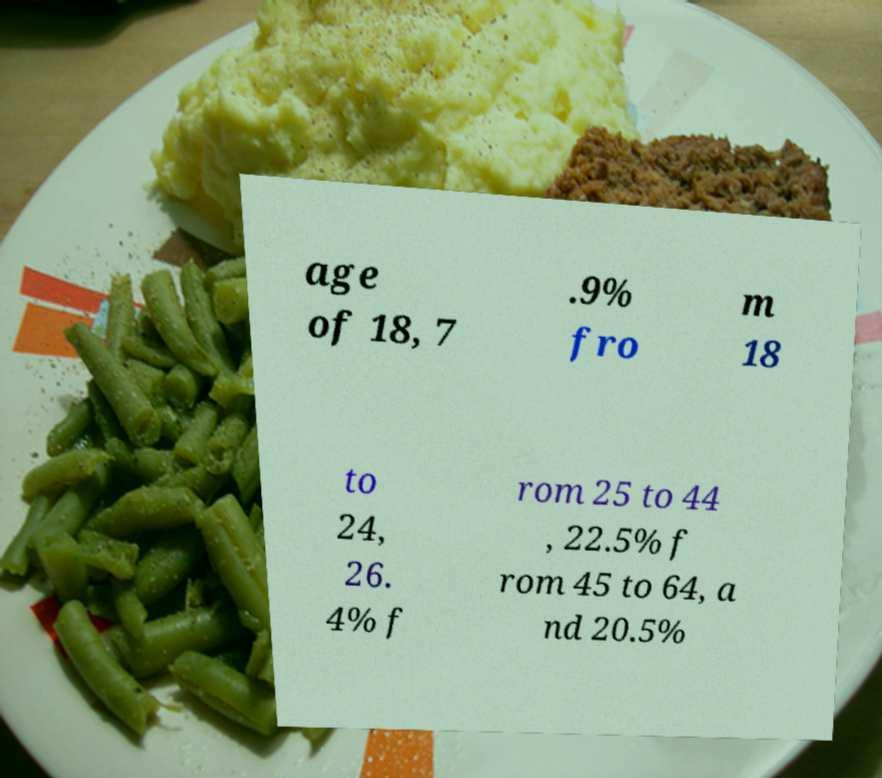Can you read and provide the text displayed in the image?This photo seems to have some interesting text. Can you extract and type it out for me? age of 18, 7 .9% fro m 18 to 24, 26. 4% f rom 25 to 44 , 22.5% f rom 45 to 64, a nd 20.5% 